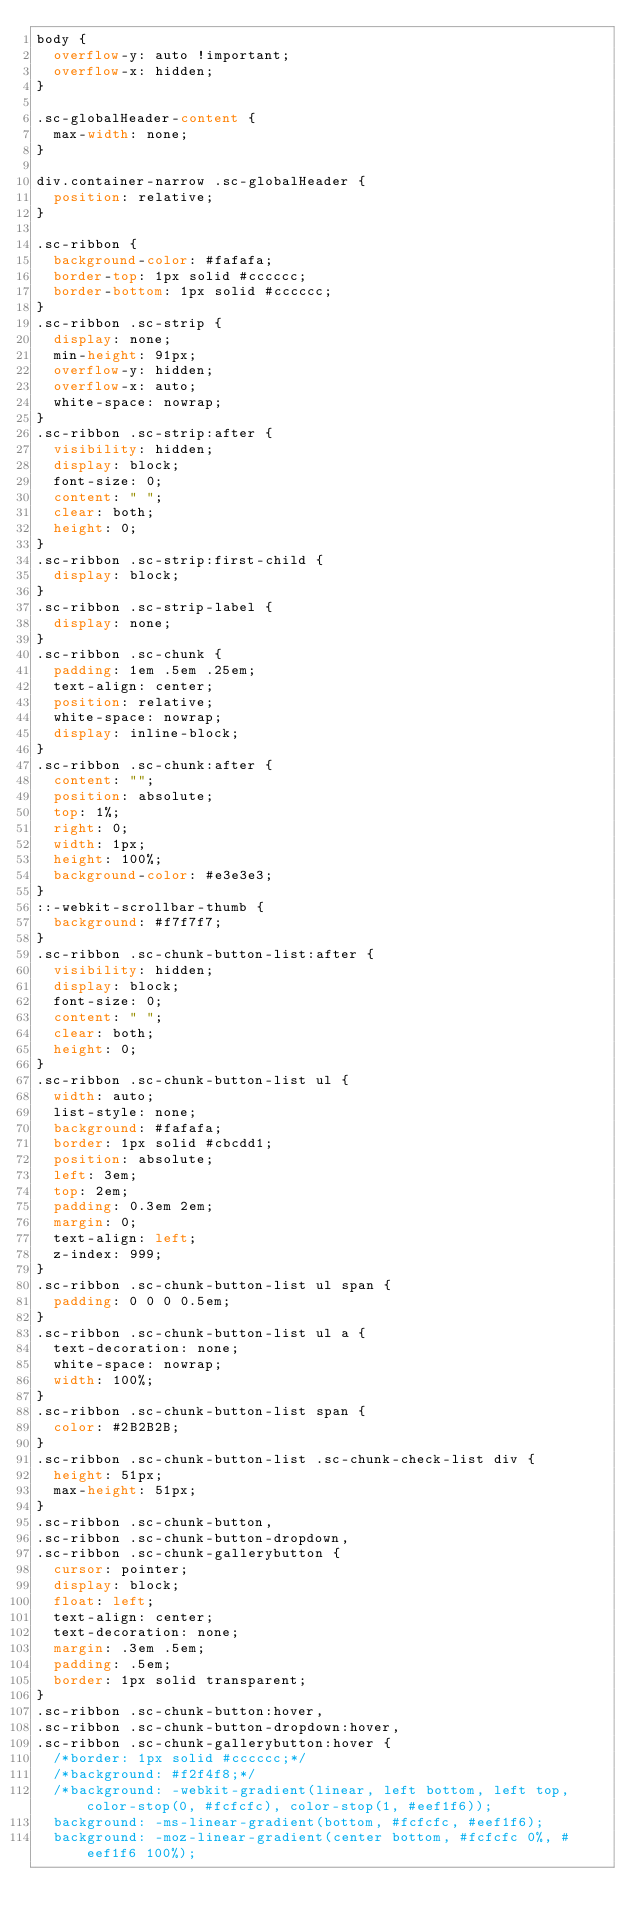Convert code to text. <code><loc_0><loc_0><loc_500><loc_500><_CSS_>body {
  overflow-y: auto !important;
  overflow-x: hidden;
}

.sc-globalHeader-content {
  max-width: none;
}

div.container-narrow .sc-globalHeader {
  position: relative;
}

.sc-ribbon {
  background-color: #fafafa;
  border-top: 1px solid #cccccc;
  border-bottom: 1px solid #cccccc;
}
.sc-ribbon .sc-strip {
  display: none;
  min-height: 91px;
  overflow-y: hidden;
  overflow-x: auto;
  white-space: nowrap;
}
.sc-ribbon .sc-strip:after {
  visibility: hidden;
  display: block;
  font-size: 0;
  content: " ";
  clear: both;
  height: 0;
}
.sc-ribbon .sc-strip:first-child {
  display: block;
}
.sc-ribbon .sc-strip-label {
  display: none;
}
.sc-ribbon .sc-chunk {
  padding: 1em .5em .25em;
  text-align: center;
  position: relative;
  white-space: nowrap;
  display: inline-block;
}
.sc-ribbon .sc-chunk:after {
  content: "";
  position: absolute;
  top: 1%;
  right: 0;
  width: 1px;
  height: 100%;
  background-color: #e3e3e3;
}
::-webkit-scrollbar-thumb {
  background: #f7f7f7;
}
.sc-ribbon .sc-chunk-button-list:after {
  visibility: hidden;
  display: block;
  font-size: 0;
  content: " ";
  clear: both;
  height: 0;
}
.sc-ribbon .sc-chunk-button-list ul {
  width: auto;
  list-style: none;
  background: #fafafa;
  border: 1px solid #cbcdd1;
  position: absolute;
  left: 3em;
  top: 2em;
  padding: 0.3em 2em;
  margin: 0;
  text-align: left;
  z-index: 999;
}
.sc-ribbon .sc-chunk-button-list ul span {
  padding: 0 0 0 0.5em;
}
.sc-ribbon .sc-chunk-button-list ul a {
  text-decoration: none;
  white-space: nowrap;
  width: 100%;
}
.sc-ribbon .sc-chunk-button-list span {
  color: #2B2B2B;
}
.sc-ribbon .sc-chunk-button-list .sc-chunk-check-list div {
  height: 51px;
  max-height: 51px;
}
.sc-ribbon .sc-chunk-button,
.sc-ribbon .sc-chunk-button-dropdown,
.sc-ribbon .sc-chunk-gallerybutton {
  cursor: pointer;
  display: block;
  float: left;
  text-align: center;
  text-decoration: none;
  margin: .3em .5em;
  padding: .5em;
  border: 1px solid transparent;
}
.sc-ribbon .sc-chunk-button:hover,
.sc-ribbon .sc-chunk-button-dropdown:hover,
.sc-ribbon .sc-chunk-gallerybutton:hover {
  /*border: 1px solid #cccccc;*/
  /*background: #f2f4f8;*/
  /*background: -webkit-gradient(linear, left bottom, left top, color-stop(0, #fcfcfc), color-stop(1, #eef1f6));
  background: -ms-linear-gradient(bottom, #fcfcfc, #eef1f6);
  background: -moz-linear-gradient(center bottom, #fcfcfc 0%, #eef1f6 100%);</code> 